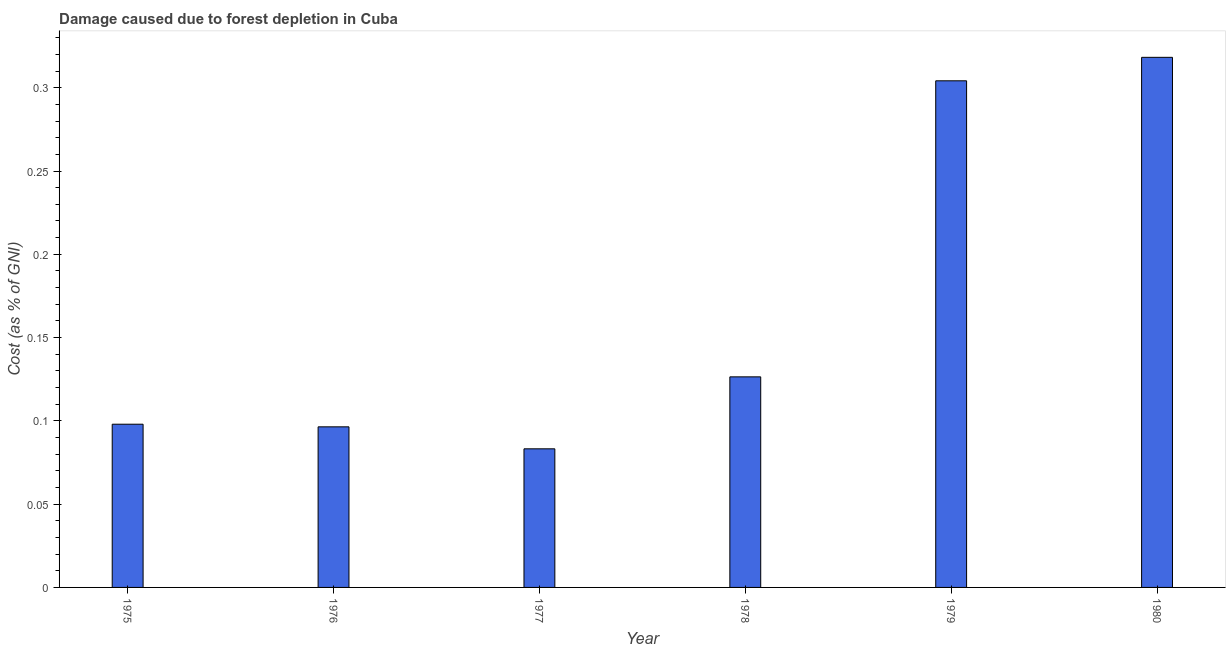Does the graph contain any zero values?
Ensure brevity in your answer.  No. Does the graph contain grids?
Provide a short and direct response. No. What is the title of the graph?
Keep it short and to the point. Damage caused due to forest depletion in Cuba. What is the label or title of the Y-axis?
Your answer should be very brief. Cost (as % of GNI). What is the damage caused due to forest depletion in 1975?
Your answer should be compact. 0.1. Across all years, what is the maximum damage caused due to forest depletion?
Your response must be concise. 0.32. Across all years, what is the minimum damage caused due to forest depletion?
Provide a short and direct response. 0.08. What is the sum of the damage caused due to forest depletion?
Keep it short and to the point. 1.03. What is the difference between the damage caused due to forest depletion in 1975 and 1976?
Offer a very short reply. 0. What is the average damage caused due to forest depletion per year?
Your answer should be very brief. 0.17. What is the median damage caused due to forest depletion?
Make the answer very short. 0.11. In how many years, is the damage caused due to forest depletion greater than 0.18 %?
Your answer should be very brief. 2. What is the ratio of the damage caused due to forest depletion in 1978 to that in 1979?
Your response must be concise. 0.42. What is the difference between the highest and the second highest damage caused due to forest depletion?
Your response must be concise. 0.01. What is the difference between the highest and the lowest damage caused due to forest depletion?
Offer a very short reply. 0.24. In how many years, is the damage caused due to forest depletion greater than the average damage caused due to forest depletion taken over all years?
Offer a terse response. 2. How many years are there in the graph?
Provide a succinct answer. 6. What is the difference between two consecutive major ticks on the Y-axis?
Your answer should be compact. 0.05. Are the values on the major ticks of Y-axis written in scientific E-notation?
Your answer should be compact. No. What is the Cost (as % of GNI) of 1975?
Your answer should be very brief. 0.1. What is the Cost (as % of GNI) in 1976?
Provide a succinct answer. 0.1. What is the Cost (as % of GNI) in 1977?
Provide a short and direct response. 0.08. What is the Cost (as % of GNI) in 1978?
Your response must be concise. 0.13. What is the Cost (as % of GNI) of 1979?
Keep it short and to the point. 0.3. What is the Cost (as % of GNI) in 1980?
Your answer should be very brief. 0.32. What is the difference between the Cost (as % of GNI) in 1975 and 1976?
Keep it short and to the point. 0. What is the difference between the Cost (as % of GNI) in 1975 and 1977?
Offer a terse response. 0.01. What is the difference between the Cost (as % of GNI) in 1975 and 1978?
Your response must be concise. -0.03. What is the difference between the Cost (as % of GNI) in 1975 and 1979?
Make the answer very short. -0.21. What is the difference between the Cost (as % of GNI) in 1975 and 1980?
Offer a terse response. -0.22. What is the difference between the Cost (as % of GNI) in 1976 and 1977?
Offer a terse response. 0.01. What is the difference between the Cost (as % of GNI) in 1976 and 1978?
Your answer should be very brief. -0.03. What is the difference between the Cost (as % of GNI) in 1976 and 1979?
Offer a terse response. -0.21. What is the difference between the Cost (as % of GNI) in 1976 and 1980?
Provide a short and direct response. -0.22. What is the difference between the Cost (as % of GNI) in 1977 and 1978?
Your response must be concise. -0.04. What is the difference between the Cost (as % of GNI) in 1977 and 1979?
Offer a terse response. -0.22. What is the difference between the Cost (as % of GNI) in 1977 and 1980?
Give a very brief answer. -0.24. What is the difference between the Cost (as % of GNI) in 1978 and 1979?
Ensure brevity in your answer.  -0.18. What is the difference between the Cost (as % of GNI) in 1978 and 1980?
Your response must be concise. -0.19. What is the difference between the Cost (as % of GNI) in 1979 and 1980?
Your response must be concise. -0.01. What is the ratio of the Cost (as % of GNI) in 1975 to that in 1977?
Provide a succinct answer. 1.18. What is the ratio of the Cost (as % of GNI) in 1975 to that in 1978?
Offer a terse response. 0.78. What is the ratio of the Cost (as % of GNI) in 1975 to that in 1979?
Make the answer very short. 0.32. What is the ratio of the Cost (as % of GNI) in 1975 to that in 1980?
Provide a short and direct response. 0.31. What is the ratio of the Cost (as % of GNI) in 1976 to that in 1977?
Keep it short and to the point. 1.16. What is the ratio of the Cost (as % of GNI) in 1976 to that in 1978?
Provide a short and direct response. 0.76. What is the ratio of the Cost (as % of GNI) in 1976 to that in 1979?
Give a very brief answer. 0.32. What is the ratio of the Cost (as % of GNI) in 1976 to that in 1980?
Make the answer very short. 0.3. What is the ratio of the Cost (as % of GNI) in 1977 to that in 1978?
Offer a very short reply. 0.66. What is the ratio of the Cost (as % of GNI) in 1977 to that in 1979?
Your answer should be very brief. 0.27. What is the ratio of the Cost (as % of GNI) in 1977 to that in 1980?
Ensure brevity in your answer.  0.26. What is the ratio of the Cost (as % of GNI) in 1978 to that in 1979?
Give a very brief answer. 0.42. What is the ratio of the Cost (as % of GNI) in 1978 to that in 1980?
Give a very brief answer. 0.4. What is the ratio of the Cost (as % of GNI) in 1979 to that in 1980?
Offer a very short reply. 0.96. 